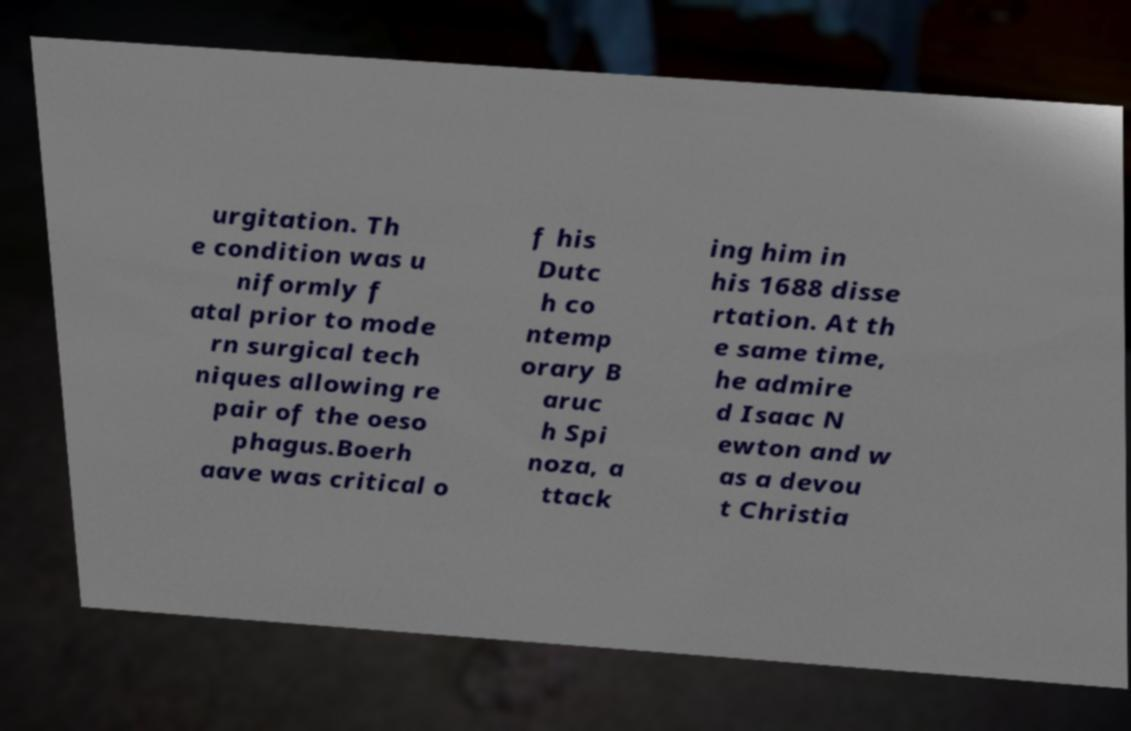Please identify and transcribe the text found in this image. urgitation. Th e condition was u niformly f atal prior to mode rn surgical tech niques allowing re pair of the oeso phagus.Boerh aave was critical o f his Dutc h co ntemp orary B aruc h Spi noza, a ttack ing him in his 1688 disse rtation. At th e same time, he admire d Isaac N ewton and w as a devou t Christia 